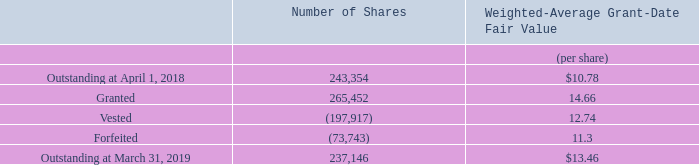Restricted Shares
We granted shares to certain of our Directors, executives and key employees under the 2016 and 2011 Plans, the vesting of which is service-based. The following table summarizes the activity during the twelve months ended March 31, 2019 for restricted shares awarded under the 2016 and 2011 Plans:
The weighted-average grant date fair value of the restricted shares is determined based upon the closing price of our common shares on the grant date. During fiscal 2019, a total of 197,917 shares, net of 47,146 shares withheld from the vested restricted shares to cover the employee's minimum applicable income taxes, were issued from treasury. The shares withheld were returned to treasury shares.
How many shares were issued from treasury in 2019? 197,917 shares, net of 47,146 shares. What were the number of outstanding shares at April 1, 2018? 243,354. What was the weighted average granted date fair value per share at April 1, 2018? $10.78. What was the difference between the granted shares and outstanding shares as at April 1, 2018? 265,452 - 243,354
Answer: 22098. What is the total  Weighted-Average Grant-Date Fair Value for Outstanding at April 1, 2018?  243,354* 10.78
Answer: 2623356.12. What was the difference between the vested and granted Weighted-Average Grant-Date Fair Value? 14.66-12.74
Answer: 1.92. 